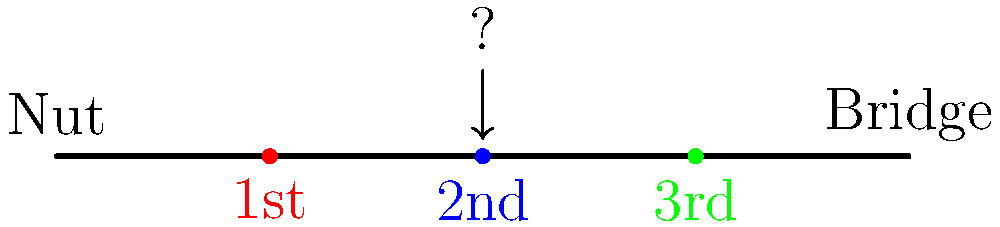In the diagram above, which finger position is indicated by the blue dot and the arrow? To answer this question, we need to analyze the visual representation of the violin fingerboard:

1. The diagram shows a simplified version of a violin fingerboard, with the nut on the left and the bridge on the right.

2. There are three colored dots on the fingerboard, representing different finger positions:
   - A red dot labeled "1st"
   - A blue dot labeled "2nd"
   - A green dot labeled "3rd"

3. The arrow is pointing directly to the blue dot.

4. In violin terminology, finger positions are numbered from 1 to 4, starting from the index finger to the pinky.

5. The blue dot is labeled "2nd", which corresponds to the middle finger (second finger) position on the fingerboard.

Therefore, the finger position indicated by the blue dot and the arrow is the second finger position.
Answer: Second finger position 